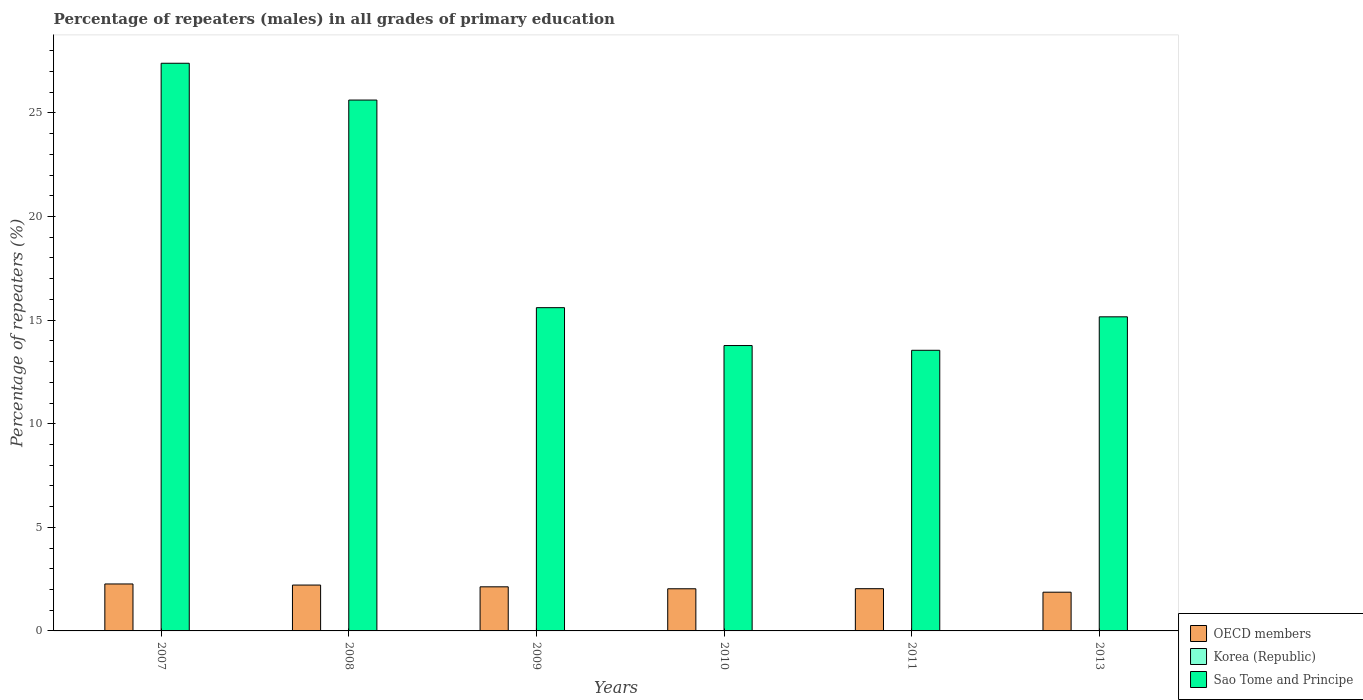How many bars are there on the 4th tick from the left?
Provide a succinct answer. 3. How many bars are there on the 4th tick from the right?
Your answer should be very brief. 3. In how many cases, is the number of bars for a given year not equal to the number of legend labels?
Provide a short and direct response. 0. What is the percentage of repeaters (males) in OECD members in 2008?
Your response must be concise. 2.21. Across all years, what is the maximum percentage of repeaters (males) in Korea (Republic)?
Offer a terse response. 0. Across all years, what is the minimum percentage of repeaters (males) in OECD members?
Your answer should be very brief. 1.87. In which year was the percentage of repeaters (males) in Korea (Republic) maximum?
Keep it short and to the point. 2010. What is the total percentage of repeaters (males) in OECD members in the graph?
Keep it short and to the point. 12.55. What is the difference between the percentage of repeaters (males) in OECD members in 2009 and that in 2011?
Your answer should be compact. 0.09. What is the difference between the percentage of repeaters (males) in Sao Tome and Principe in 2008 and the percentage of repeaters (males) in Korea (Republic) in 2010?
Keep it short and to the point. 25.62. What is the average percentage of repeaters (males) in OECD members per year?
Offer a terse response. 2.09. In the year 2011, what is the difference between the percentage of repeaters (males) in Sao Tome and Principe and percentage of repeaters (males) in OECD members?
Make the answer very short. 11.51. In how many years, is the percentage of repeaters (males) in Sao Tome and Principe greater than 11 %?
Your response must be concise. 6. What is the ratio of the percentage of repeaters (males) in OECD members in 2007 to that in 2008?
Your answer should be compact. 1.02. Is the percentage of repeaters (males) in OECD members in 2007 less than that in 2013?
Provide a short and direct response. No. Is the difference between the percentage of repeaters (males) in Sao Tome and Principe in 2008 and 2010 greater than the difference between the percentage of repeaters (males) in OECD members in 2008 and 2010?
Your answer should be compact. Yes. What is the difference between the highest and the second highest percentage of repeaters (males) in Korea (Republic)?
Keep it short and to the point. 0. What is the difference between the highest and the lowest percentage of repeaters (males) in Korea (Republic)?
Offer a terse response. 0. Is the sum of the percentage of repeaters (males) in OECD members in 2009 and 2010 greater than the maximum percentage of repeaters (males) in Sao Tome and Principe across all years?
Ensure brevity in your answer.  No. What does the 2nd bar from the left in 2013 represents?
Your answer should be compact. Korea (Republic). What does the 1st bar from the right in 2008 represents?
Offer a terse response. Sao Tome and Principe. Is it the case that in every year, the sum of the percentage of repeaters (males) in Sao Tome and Principe and percentage of repeaters (males) in Korea (Republic) is greater than the percentage of repeaters (males) in OECD members?
Give a very brief answer. Yes. How many bars are there?
Your answer should be compact. 18. Are the values on the major ticks of Y-axis written in scientific E-notation?
Provide a succinct answer. No. Does the graph contain grids?
Provide a short and direct response. No. Where does the legend appear in the graph?
Your answer should be compact. Bottom right. How many legend labels are there?
Provide a short and direct response. 3. How are the legend labels stacked?
Offer a very short reply. Vertical. What is the title of the graph?
Make the answer very short. Percentage of repeaters (males) in all grades of primary education. Does "Azerbaijan" appear as one of the legend labels in the graph?
Give a very brief answer. No. What is the label or title of the Y-axis?
Make the answer very short. Percentage of repeaters (%). What is the Percentage of repeaters (%) in OECD members in 2007?
Make the answer very short. 2.27. What is the Percentage of repeaters (%) in Korea (Republic) in 2007?
Your answer should be compact. 0. What is the Percentage of repeaters (%) of Sao Tome and Principe in 2007?
Offer a very short reply. 27.4. What is the Percentage of repeaters (%) in OECD members in 2008?
Offer a very short reply. 2.21. What is the Percentage of repeaters (%) in Korea (Republic) in 2008?
Give a very brief answer. 0. What is the Percentage of repeaters (%) of Sao Tome and Principe in 2008?
Give a very brief answer. 25.62. What is the Percentage of repeaters (%) in OECD members in 2009?
Your response must be concise. 2.13. What is the Percentage of repeaters (%) of Korea (Republic) in 2009?
Your answer should be very brief. 0. What is the Percentage of repeaters (%) in Sao Tome and Principe in 2009?
Offer a terse response. 15.6. What is the Percentage of repeaters (%) in OECD members in 2010?
Your answer should be very brief. 2.03. What is the Percentage of repeaters (%) of Korea (Republic) in 2010?
Offer a very short reply. 0. What is the Percentage of repeaters (%) in Sao Tome and Principe in 2010?
Provide a short and direct response. 13.77. What is the Percentage of repeaters (%) in OECD members in 2011?
Your answer should be very brief. 2.04. What is the Percentage of repeaters (%) in Korea (Republic) in 2011?
Provide a succinct answer. 0. What is the Percentage of repeaters (%) of Sao Tome and Principe in 2011?
Offer a very short reply. 13.54. What is the Percentage of repeaters (%) of OECD members in 2013?
Provide a succinct answer. 1.87. What is the Percentage of repeaters (%) in Korea (Republic) in 2013?
Keep it short and to the point. 0. What is the Percentage of repeaters (%) in Sao Tome and Principe in 2013?
Offer a very short reply. 15.16. Across all years, what is the maximum Percentage of repeaters (%) of OECD members?
Provide a succinct answer. 2.27. Across all years, what is the maximum Percentage of repeaters (%) of Korea (Republic)?
Provide a succinct answer. 0. Across all years, what is the maximum Percentage of repeaters (%) of Sao Tome and Principe?
Your answer should be very brief. 27.4. Across all years, what is the minimum Percentage of repeaters (%) in OECD members?
Make the answer very short. 1.87. Across all years, what is the minimum Percentage of repeaters (%) of Korea (Republic)?
Give a very brief answer. 0. Across all years, what is the minimum Percentage of repeaters (%) in Sao Tome and Principe?
Offer a very short reply. 13.54. What is the total Percentage of repeaters (%) of OECD members in the graph?
Provide a short and direct response. 12.55. What is the total Percentage of repeaters (%) of Korea (Republic) in the graph?
Ensure brevity in your answer.  0.02. What is the total Percentage of repeaters (%) of Sao Tome and Principe in the graph?
Provide a succinct answer. 111.1. What is the difference between the Percentage of repeaters (%) of OECD members in 2007 and that in 2008?
Make the answer very short. 0.05. What is the difference between the Percentage of repeaters (%) in Sao Tome and Principe in 2007 and that in 2008?
Make the answer very short. 1.78. What is the difference between the Percentage of repeaters (%) of OECD members in 2007 and that in 2009?
Provide a short and direct response. 0.14. What is the difference between the Percentage of repeaters (%) of Korea (Republic) in 2007 and that in 2009?
Your answer should be very brief. 0. What is the difference between the Percentage of repeaters (%) of Sao Tome and Principe in 2007 and that in 2009?
Ensure brevity in your answer.  11.8. What is the difference between the Percentage of repeaters (%) of OECD members in 2007 and that in 2010?
Your answer should be very brief. 0.23. What is the difference between the Percentage of repeaters (%) in Korea (Republic) in 2007 and that in 2010?
Provide a succinct answer. -0. What is the difference between the Percentage of repeaters (%) in Sao Tome and Principe in 2007 and that in 2010?
Offer a very short reply. 13.62. What is the difference between the Percentage of repeaters (%) of OECD members in 2007 and that in 2011?
Your answer should be very brief. 0.23. What is the difference between the Percentage of repeaters (%) of Korea (Republic) in 2007 and that in 2011?
Your answer should be very brief. 0. What is the difference between the Percentage of repeaters (%) of Sao Tome and Principe in 2007 and that in 2011?
Provide a succinct answer. 13.85. What is the difference between the Percentage of repeaters (%) in OECD members in 2007 and that in 2013?
Provide a succinct answer. 0.4. What is the difference between the Percentage of repeaters (%) in Korea (Republic) in 2007 and that in 2013?
Offer a very short reply. -0. What is the difference between the Percentage of repeaters (%) in Sao Tome and Principe in 2007 and that in 2013?
Ensure brevity in your answer.  12.24. What is the difference between the Percentage of repeaters (%) in OECD members in 2008 and that in 2009?
Your response must be concise. 0.08. What is the difference between the Percentage of repeaters (%) of Korea (Republic) in 2008 and that in 2009?
Make the answer very short. 0. What is the difference between the Percentage of repeaters (%) in Sao Tome and Principe in 2008 and that in 2009?
Provide a short and direct response. 10.02. What is the difference between the Percentage of repeaters (%) of OECD members in 2008 and that in 2010?
Your answer should be compact. 0.18. What is the difference between the Percentage of repeaters (%) in Korea (Republic) in 2008 and that in 2010?
Make the answer very short. -0. What is the difference between the Percentage of repeaters (%) in Sao Tome and Principe in 2008 and that in 2010?
Your answer should be very brief. 11.85. What is the difference between the Percentage of repeaters (%) in OECD members in 2008 and that in 2011?
Your answer should be very brief. 0.18. What is the difference between the Percentage of repeaters (%) of Korea (Republic) in 2008 and that in 2011?
Your answer should be very brief. 0. What is the difference between the Percentage of repeaters (%) of Sao Tome and Principe in 2008 and that in 2011?
Make the answer very short. 12.08. What is the difference between the Percentage of repeaters (%) of OECD members in 2008 and that in 2013?
Make the answer very short. 0.34. What is the difference between the Percentage of repeaters (%) in Korea (Republic) in 2008 and that in 2013?
Make the answer very short. -0. What is the difference between the Percentage of repeaters (%) of Sao Tome and Principe in 2008 and that in 2013?
Offer a very short reply. 10.46. What is the difference between the Percentage of repeaters (%) in OECD members in 2009 and that in 2010?
Provide a succinct answer. 0.09. What is the difference between the Percentage of repeaters (%) in Korea (Republic) in 2009 and that in 2010?
Your response must be concise. -0. What is the difference between the Percentage of repeaters (%) in Sao Tome and Principe in 2009 and that in 2010?
Offer a very short reply. 1.83. What is the difference between the Percentage of repeaters (%) in OECD members in 2009 and that in 2011?
Provide a succinct answer. 0.09. What is the difference between the Percentage of repeaters (%) in Korea (Republic) in 2009 and that in 2011?
Offer a very short reply. -0. What is the difference between the Percentage of repeaters (%) in Sao Tome and Principe in 2009 and that in 2011?
Ensure brevity in your answer.  2.06. What is the difference between the Percentage of repeaters (%) in OECD members in 2009 and that in 2013?
Offer a terse response. 0.26. What is the difference between the Percentage of repeaters (%) in Korea (Republic) in 2009 and that in 2013?
Keep it short and to the point. -0. What is the difference between the Percentage of repeaters (%) in Sao Tome and Principe in 2009 and that in 2013?
Your response must be concise. 0.44. What is the difference between the Percentage of repeaters (%) in OECD members in 2010 and that in 2011?
Your answer should be very brief. -0. What is the difference between the Percentage of repeaters (%) of Korea (Republic) in 2010 and that in 2011?
Your response must be concise. 0. What is the difference between the Percentage of repeaters (%) of Sao Tome and Principe in 2010 and that in 2011?
Offer a terse response. 0.23. What is the difference between the Percentage of repeaters (%) in OECD members in 2010 and that in 2013?
Offer a very short reply. 0.17. What is the difference between the Percentage of repeaters (%) in Sao Tome and Principe in 2010 and that in 2013?
Ensure brevity in your answer.  -1.39. What is the difference between the Percentage of repeaters (%) in OECD members in 2011 and that in 2013?
Provide a succinct answer. 0.17. What is the difference between the Percentage of repeaters (%) in Korea (Republic) in 2011 and that in 2013?
Ensure brevity in your answer.  -0. What is the difference between the Percentage of repeaters (%) in Sao Tome and Principe in 2011 and that in 2013?
Offer a very short reply. -1.62. What is the difference between the Percentage of repeaters (%) in OECD members in 2007 and the Percentage of repeaters (%) in Korea (Republic) in 2008?
Keep it short and to the point. 2.26. What is the difference between the Percentage of repeaters (%) of OECD members in 2007 and the Percentage of repeaters (%) of Sao Tome and Principe in 2008?
Give a very brief answer. -23.35. What is the difference between the Percentage of repeaters (%) in Korea (Republic) in 2007 and the Percentage of repeaters (%) in Sao Tome and Principe in 2008?
Your answer should be compact. -25.62. What is the difference between the Percentage of repeaters (%) of OECD members in 2007 and the Percentage of repeaters (%) of Korea (Republic) in 2009?
Provide a succinct answer. 2.26. What is the difference between the Percentage of repeaters (%) in OECD members in 2007 and the Percentage of repeaters (%) in Sao Tome and Principe in 2009?
Offer a terse response. -13.34. What is the difference between the Percentage of repeaters (%) of Korea (Republic) in 2007 and the Percentage of repeaters (%) of Sao Tome and Principe in 2009?
Offer a terse response. -15.6. What is the difference between the Percentage of repeaters (%) in OECD members in 2007 and the Percentage of repeaters (%) in Korea (Republic) in 2010?
Make the answer very short. 2.26. What is the difference between the Percentage of repeaters (%) of OECD members in 2007 and the Percentage of repeaters (%) of Sao Tome and Principe in 2010?
Keep it short and to the point. -11.51. What is the difference between the Percentage of repeaters (%) of Korea (Republic) in 2007 and the Percentage of repeaters (%) of Sao Tome and Principe in 2010?
Your answer should be very brief. -13.77. What is the difference between the Percentage of repeaters (%) of OECD members in 2007 and the Percentage of repeaters (%) of Korea (Republic) in 2011?
Your answer should be compact. 2.26. What is the difference between the Percentage of repeaters (%) of OECD members in 2007 and the Percentage of repeaters (%) of Sao Tome and Principe in 2011?
Make the answer very short. -11.28. What is the difference between the Percentage of repeaters (%) of Korea (Republic) in 2007 and the Percentage of repeaters (%) of Sao Tome and Principe in 2011?
Keep it short and to the point. -13.54. What is the difference between the Percentage of repeaters (%) in OECD members in 2007 and the Percentage of repeaters (%) in Korea (Republic) in 2013?
Ensure brevity in your answer.  2.26. What is the difference between the Percentage of repeaters (%) of OECD members in 2007 and the Percentage of repeaters (%) of Sao Tome and Principe in 2013?
Your answer should be very brief. -12.89. What is the difference between the Percentage of repeaters (%) in Korea (Republic) in 2007 and the Percentage of repeaters (%) in Sao Tome and Principe in 2013?
Provide a short and direct response. -15.16. What is the difference between the Percentage of repeaters (%) of OECD members in 2008 and the Percentage of repeaters (%) of Korea (Republic) in 2009?
Your answer should be very brief. 2.21. What is the difference between the Percentage of repeaters (%) in OECD members in 2008 and the Percentage of repeaters (%) in Sao Tome and Principe in 2009?
Give a very brief answer. -13.39. What is the difference between the Percentage of repeaters (%) in Korea (Republic) in 2008 and the Percentage of repeaters (%) in Sao Tome and Principe in 2009?
Give a very brief answer. -15.6. What is the difference between the Percentage of repeaters (%) of OECD members in 2008 and the Percentage of repeaters (%) of Korea (Republic) in 2010?
Make the answer very short. 2.21. What is the difference between the Percentage of repeaters (%) in OECD members in 2008 and the Percentage of repeaters (%) in Sao Tome and Principe in 2010?
Your answer should be very brief. -11.56. What is the difference between the Percentage of repeaters (%) of Korea (Republic) in 2008 and the Percentage of repeaters (%) of Sao Tome and Principe in 2010?
Your answer should be compact. -13.77. What is the difference between the Percentage of repeaters (%) in OECD members in 2008 and the Percentage of repeaters (%) in Korea (Republic) in 2011?
Give a very brief answer. 2.21. What is the difference between the Percentage of repeaters (%) of OECD members in 2008 and the Percentage of repeaters (%) of Sao Tome and Principe in 2011?
Your response must be concise. -11.33. What is the difference between the Percentage of repeaters (%) of Korea (Republic) in 2008 and the Percentage of repeaters (%) of Sao Tome and Principe in 2011?
Keep it short and to the point. -13.54. What is the difference between the Percentage of repeaters (%) in OECD members in 2008 and the Percentage of repeaters (%) in Korea (Republic) in 2013?
Provide a succinct answer. 2.21. What is the difference between the Percentage of repeaters (%) of OECD members in 2008 and the Percentage of repeaters (%) of Sao Tome and Principe in 2013?
Your response must be concise. -12.95. What is the difference between the Percentage of repeaters (%) of Korea (Republic) in 2008 and the Percentage of repeaters (%) of Sao Tome and Principe in 2013?
Your response must be concise. -15.16. What is the difference between the Percentage of repeaters (%) in OECD members in 2009 and the Percentage of repeaters (%) in Korea (Republic) in 2010?
Your answer should be very brief. 2.12. What is the difference between the Percentage of repeaters (%) of OECD members in 2009 and the Percentage of repeaters (%) of Sao Tome and Principe in 2010?
Your answer should be compact. -11.65. What is the difference between the Percentage of repeaters (%) of Korea (Republic) in 2009 and the Percentage of repeaters (%) of Sao Tome and Principe in 2010?
Provide a succinct answer. -13.77. What is the difference between the Percentage of repeaters (%) in OECD members in 2009 and the Percentage of repeaters (%) in Korea (Republic) in 2011?
Give a very brief answer. 2.13. What is the difference between the Percentage of repeaters (%) of OECD members in 2009 and the Percentage of repeaters (%) of Sao Tome and Principe in 2011?
Offer a very short reply. -11.42. What is the difference between the Percentage of repeaters (%) in Korea (Republic) in 2009 and the Percentage of repeaters (%) in Sao Tome and Principe in 2011?
Your response must be concise. -13.54. What is the difference between the Percentage of repeaters (%) of OECD members in 2009 and the Percentage of repeaters (%) of Korea (Republic) in 2013?
Provide a short and direct response. 2.13. What is the difference between the Percentage of repeaters (%) of OECD members in 2009 and the Percentage of repeaters (%) of Sao Tome and Principe in 2013?
Your response must be concise. -13.03. What is the difference between the Percentage of repeaters (%) of Korea (Republic) in 2009 and the Percentage of repeaters (%) of Sao Tome and Principe in 2013?
Provide a short and direct response. -15.16. What is the difference between the Percentage of repeaters (%) in OECD members in 2010 and the Percentage of repeaters (%) in Korea (Republic) in 2011?
Offer a terse response. 2.03. What is the difference between the Percentage of repeaters (%) of OECD members in 2010 and the Percentage of repeaters (%) of Sao Tome and Principe in 2011?
Your answer should be compact. -11.51. What is the difference between the Percentage of repeaters (%) of Korea (Republic) in 2010 and the Percentage of repeaters (%) of Sao Tome and Principe in 2011?
Your answer should be very brief. -13.54. What is the difference between the Percentage of repeaters (%) in OECD members in 2010 and the Percentage of repeaters (%) in Korea (Republic) in 2013?
Keep it short and to the point. 2.03. What is the difference between the Percentage of repeaters (%) of OECD members in 2010 and the Percentage of repeaters (%) of Sao Tome and Principe in 2013?
Give a very brief answer. -13.13. What is the difference between the Percentage of repeaters (%) in Korea (Republic) in 2010 and the Percentage of repeaters (%) in Sao Tome and Principe in 2013?
Offer a very short reply. -15.16. What is the difference between the Percentage of repeaters (%) in OECD members in 2011 and the Percentage of repeaters (%) in Korea (Republic) in 2013?
Provide a short and direct response. 2.04. What is the difference between the Percentage of repeaters (%) in OECD members in 2011 and the Percentage of repeaters (%) in Sao Tome and Principe in 2013?
Give a very brief answer. -13.12. What is the difference between the Percentage of repeaters (%) of Korea (Republic) in 2011 and the Percentage of repeaters (%) of Sao Tome and Principe in 2013?
Your answer should be very brief. -15.16. What is the average Percentage of repeaters (%) of OECD members per year?
Keep it short and to the point. 2.09. What is the average Percentage of repeaters (%) of Korea (Republic) per year?
Provide a succinct answer. 0. What is the average Percentage of repeaters (%) of Sao Tome and Principe per year?
Your answer should be very brief. 18.52. In the year 2007, what is the difference between the Percentage of repeaters (%) in OECD members and Percentage of repeaters (%) in Korea (Republic)?
Your answer should be compact. 2.26. In the year 2007, what is the difference between the Percentage of repeaters (%) in OECD members and Percentage of repeaters (%) in Sao Tome and Principe?
Provide a short and direct response. -25.13. In the year 2007, what is the difference between the Percentage of repeaters (%) in Korea (Republic) and Percentage of repeaters (%) in Sao Tome and Principe?
Offer a very short reply. -27.39. In the year 2008, what is the difference between the Percentage of repeaters (%) in OECD members and Percentage of repeaters (%) in Korea (Republic)?
Keep it short and to the point. 2.21. In the year 2008, what is the difference between the Percentage of repeaters (%) in OECD members and Percentage of repeaters (%) in Sao Tome and Principe?
Make the answer very short. -23.41. In the year 2008, what is the difference between the Percentage of repeaters (%) in Korea (Republic) and Percentage of repeaters (%) in Sao Tome and Principe?
Your response must be concise. -25.62. In the year 2009, what is the difference between the Percentage of repeaters (%) of OECD members and Percentage of repeaters (%) of Korea (Republic)?
Offer a very short reply. 2.13. In the year 2009, what is the difference between the Percentage of repeaters (%) of OECD members and Percentage of repeaters (%) of Sao Tome and Principe?
Offer a terse response. -13.47. In the year 2009, what is the difference between the Percentage of repeaters (%) in Korea (Republic) and Percentage of repeaters (%) in Sao Tome and Principe?
Provide a short and direct response. -15.6. In the year 2010, what is the difference between the Percentage of repeaters (%) in OECD members and Percentage of repeaters (%) in Korea (Republic)?
Offer a very short reply. 2.03. In the year 2010, what is the difference between the Percentage of repeaters (%) of OECD members and Percentage of repeaters (%) of Sao Tome and Principe?
Give a very brief answer. -11.74. In the year 2010, what is the difference between the Percentage of repeaters (%) in Korea (Republic) and Percentage of repeaters (%) in Sao Tome and Principe?
Your answer should be compact. -13.77. In the year 2011, what is the difference between the Percentage of repeaters (%) of OECD members and Percentage of repeaters (%) of Korea (Republic)?
Provide a succinct answer. 2.04. In the year 2011, what is the difference between the Percentage of repeaters (%) of OECD members and Percentage of repeaters (%) of Sao Tome and Principe?
Make the answer very short. -11.51. In the year 2011, what is the difference between the Percentage of repeaters (%) in Korea (Republic) and Percentage of repeaters (%) in Sao Tome and Principe?
Ensure brevity in your answer.  -13.54. In the year 2013, what is the difference between the Percentage of repeaters (%) in OECD members and Percentage of repeaters (%) in Korea (Republic)?
Your answer should be very brief. 1.87. In the year 2013, what is the difference between the Percentage of repeaters (%) in OECD members and Percentage of repeaters (%) in Sao Tome and Principe?
Your answer should be compact. -13.29. In the year 2013, what is the difference between the Percentage of repeaters (%) in Korea (Republic) and Percentage of repeaters (%) in Sao Tome and Principe?
Offer a terse response. -15.16. What is the ratio of the Percentage of repeaters (%) in OECD members in 2007 to that in 2008?
Your answer should be compact. 1.02. What is the ratio of the Percentage of repeaters (%) of Korea (Republic) in 2007 to that in 2008?
Your answer should be compact. 1.15. What is the ratio of the Percentage of repeaters (%) of Sao Tome and Principe in 2007 to that in 2008?
Provide a short and direct response. 1.07. What is the ratio of the Percentage of repeaters (%) in OECD members in 2007 to that in 2009?
Offer a very short reply. 1.06. What is the ratio of the Percentage of repeaters (%) in Korea (Republic) in 2007 to that in 2009?
Give a very brief answer. 1.4. What is the ratio of the Percentage of repeaters (%) of Sao Tome and Principe in 2007 to that in 2009?
Keep it short and to the point. 1.76. What is the ratio of the Percentage of repeaters (%) in OECD members in 2007 to that in 2010?
Ensure brevity in your answer.  1.11. What is the ratio of the Percentage of repeaters (%) of Korea (Republic) in 2007 to that in 2010?
Make the answer very short. 0.78. What is the ratio of the Percentage of repeaters (%) in Sao Tome and Principe in 2007 to that in 2010?
Offer a very short reply. 1.99. What is the ratio of the Percentage of repeaters (%) in OECD members in 2007 to that in 2011?
Keep it short and to the point. 1.11. What is the ratio of the Percentage of repeaters (%) of Korea (Republic) in 2007 to that in 2011?
Offer a very short reply. 1.3. What is the ratio of the Percentage of repeaters (%) in Sao Tome and Principe in 2007 to that in 2011?
Ensure brevity in your answer.  2.02. What is the ratio of the Percentage of repeaters (%) of OECD members in 2007 to that in 2013?
Offer a very short reply. 1.21. What is the ratio of the Percentage of repeaters (%) of Korea (Republic) in 2007 to that in 2013?
Your answer should be compact. 0.9. What is the ratio of the Percentage of repeaters (%) of Sao Tome and Principe in 2007 to that in 2013?
Your answer should be very brief. 1.81. What is the ratio of the Percentage of repeaters (%) of OECD members in 2008 to that in 2009?
Provide a short and direct response. 1.04. What is the ratio of the Percentage of repeaters (%) of Korea (Republic) in 2008 to that in 2009?
Give a very brief answer. 1.22. What is the ratio of the Percentage of repeaters (%) in Sao Tome and Principe in 2008 to that in 2009?
Your answer should be very brief. 1.64. What is the ratio of the Percentage of repeaters (%) in OECD members in 2008 to that in 2010?
Offer a very short reply. 1.09. What is the ratio of the Percentage of repeaters (%) of Korea (Republic) in 2008 to that in 2010?
Your answer should be very brief. 0.68. What is the ratio of the Percentage of repeaters (%) in Sao Tome and Principe in 2008 to that in 2010?
Offer a terse response. 1.86. What is the ratio of the Percentage of repeaters (%) of OECD members in 2008 to that in 2011?
Your answer should be compact. 1.09. What is the ratio of the Percentage of repeaters (%) in Korea (Republic) in 2008 to that in 2011?
Offer a very short reply. 1.13. What is the ratio of the Percentage of repeaters (%) in Sao Tome and Principe in 2008 to that in 2011?
Keep it short and to the point. 1.89. What is the ratio of the Percentage of repeaters (%) of OECD members in 2008 to that in 2013?
Make the answer very short. 1.18. What is the ratio of the Percentage of repeaters (%) of Korea (Republic) in 2008 to that in 2013?
Your answer should be compact. 0.79. What is the ratio of the Percentage of repeaters (%) of Sao Tome and Principe in 2008 to that in 2013?
Make the answer very short. 1.69. What is the ratio of the Percentage of repeaters (%) in OECD members in 2009 to that in 2010?
Ensure brevity in your answer.  1.05. What is the ratio of the Percentage of repeaters (%) of Korea (Republic) in 2009 to that in 2010?
Provide a succinct answer. 0.56. What is the ratio of the Percentage of repeaters (%) in Sao Tome and Principe in 2009 to that in 2010?
Provide a succinct answer. 1.13. What is the ratio of the Percentage of repeaters (%) of OECD members in 2009 to that in 2011?
Ensure brevity in your answer.  1.04. What is the ratio of the Percentage of repeaters (%) of Korea (Republic) in 2009 to that in 2011?
Your answer should be compact. 0.92. What is the ratio of the Percentage of repeaters (%) of Sao Tome and Principe in 2009 to that in 2011?
Make the answer very short. 1.15. What is the ratio of the Percentage of repeaters (%) in OECD members in 2009 to that in 2013?
Provide a short and direct response. 1.14. What is the ratio of the Percentage of repeaters (%) of Korea (Republic) in 2009 to that in 2013?
Offer a terse response. 0.65. What is the ratio of the Percentage of repeaters (%) in Sao Tome and Principe in 2009 to that in 2013?
Your answer should be compact. 1.03. What is the ratio of the Percentage of repeaters (%) of OECD members in 2010 to that in 2011?
Your answer should be compact. 1. What is the ratio of the Percentage of repeaters (%) in Korea (Republic) in 2010 to that in 2011?
Provide a short and direct response. 1.66. What is the ratio of the Percentage of repeaters (%) in OECD members in 2010 to that in 2013?
Provide a short and direct response. 1.09. What is the ratio of the Percentage of repeaters (%) of Korea (Republic) in 2010 to that in 2013?
Your answer should be compact. 1.16. What is the ratio of the Percentage of repeaters (%) in Sao Tome and Principe in 2010 to that in 2013?
Offer a terse response. 0.91. What is the ratio of the Percentage of repeaters (%) of OECD members in 2011 to that in 2013?
Ensure brevity in your answer.  1.09. What is the ratio of the Percentage of repeaters (%) in Korea (Republic) in 2011 to that in 2013?
Your answer should be compact. 0.7. What is the ratio of the Percentage of repeaters (%) in Sao Tome and Principe in 2011 to that in 2013?
Offer a very short reply. 0.89. What is the difference between the highest and the second highest Percentage of repeaters (%) of OECD members?
Keep it short and to the point. 0.05. What is the difference between the highest and the second highest Percentage of repeaters (%) in Sao Tome and Principe?
Provide a short and direct response. 1.78. What is the difference between the highest and the lowest Percentage of repeaters (%) in OECD members?
Offer a very short reply. 0.4. What is the difference between the highest and the lowest Percentage of repeaters (%) in Korea (Republic)?
Keep it short and to the point. 0. What is the difference between the highest and the lowest Percentage of repeaters (%) in Sao Tome and Principe?
Your answer should be very brief. 13.85. 